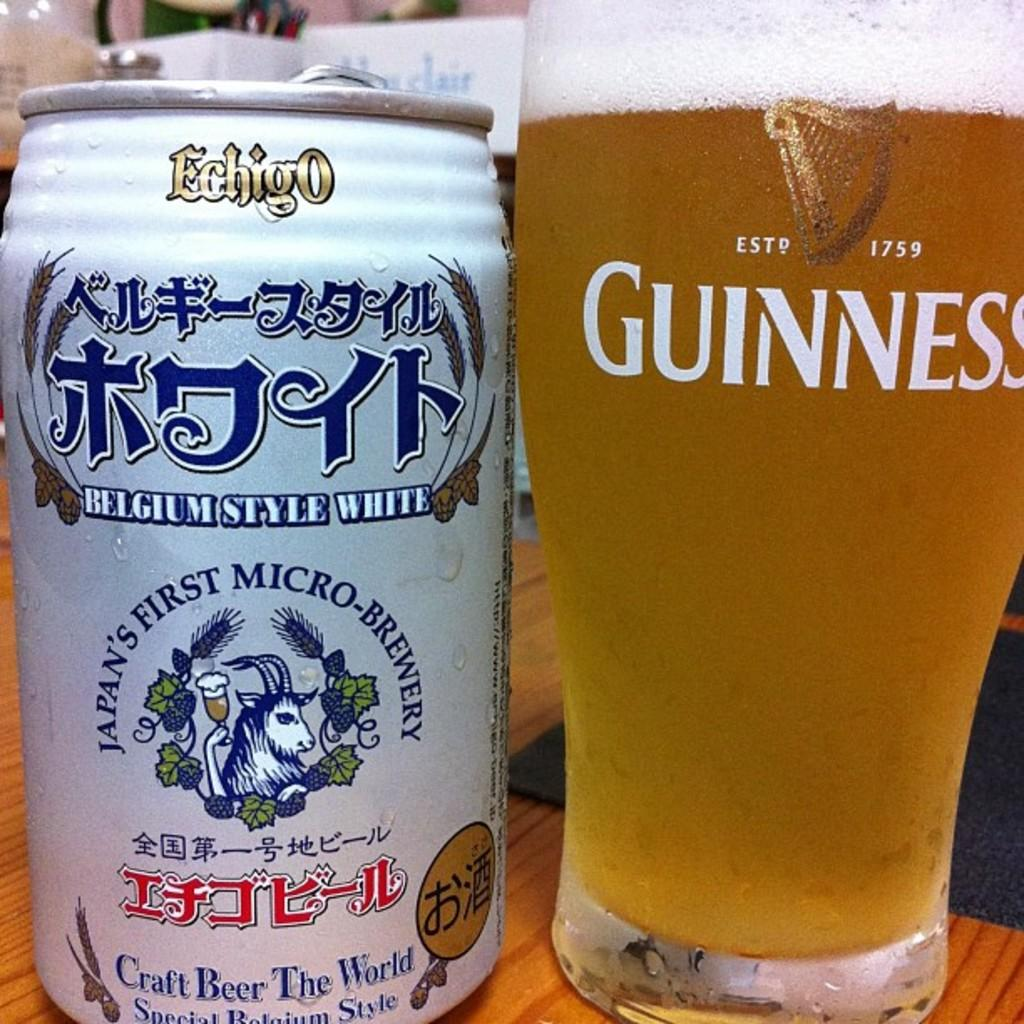<image>
Give a short and clear explanation of the subsequent image. A glass has Guinness in white letters and the year of 1759. 